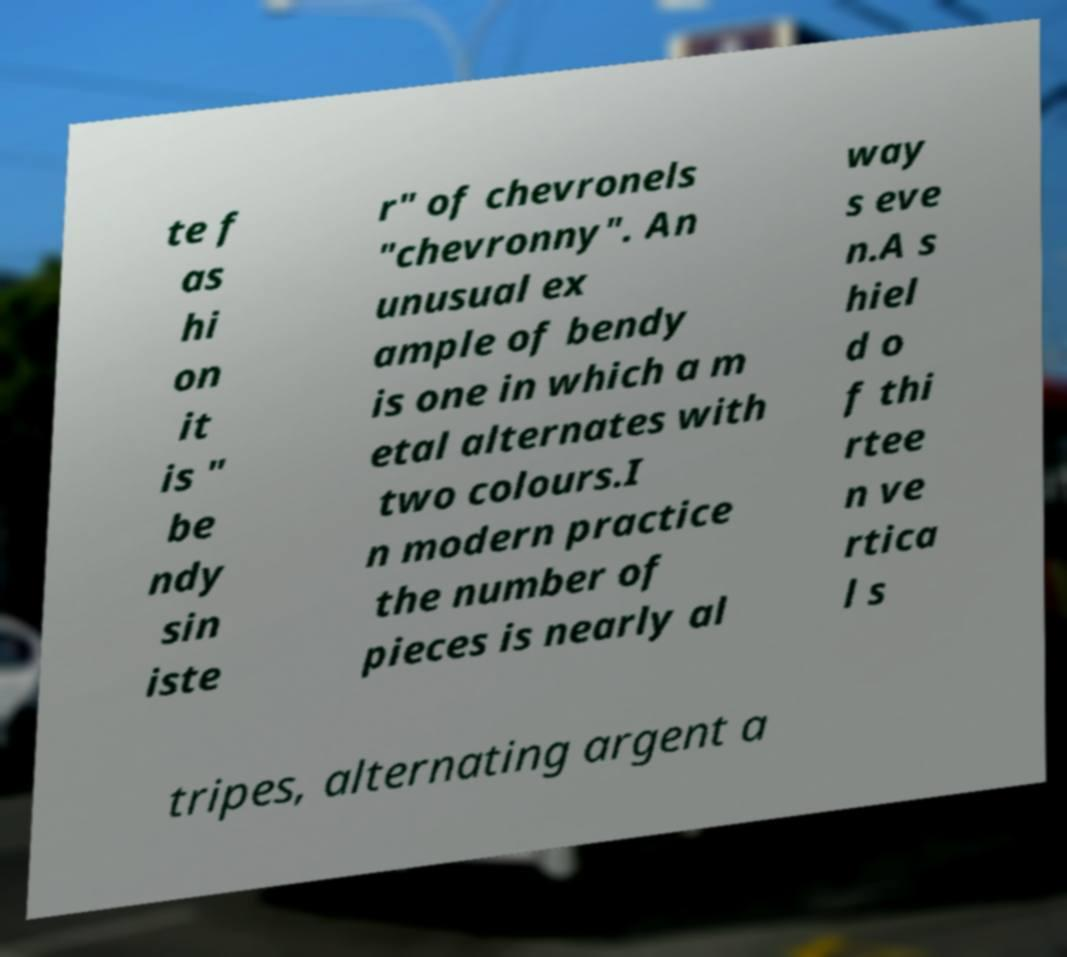Please read and relay the text visible in this image. What does it say? te f as hi on it is " be ndy sin iste r" of chevronels "chevronny". An unusual ex ample of bendy is one in which a m etal alternates with two colours.I n modern practice the number of pieces is nearly al way s eve n.A s hiel d o f thi rtee n ve rtica l s tripes, alternating argent a 